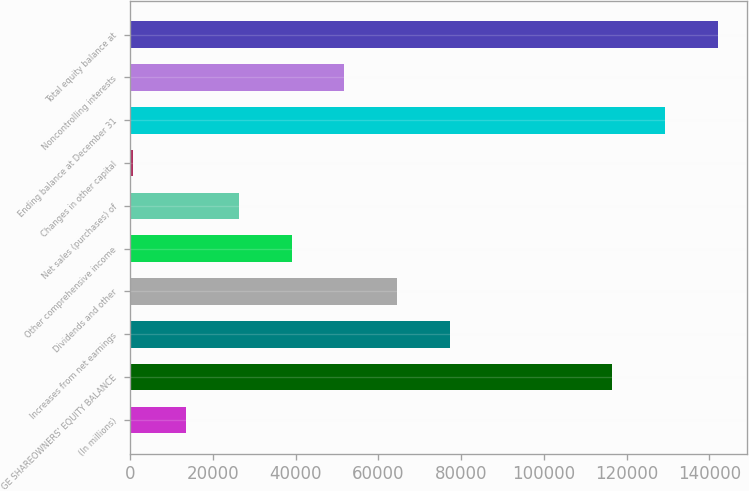Convert chart to OTSL. <chart><loc_0><loc_0><loc_500><loc_500><bar_chart><fcel>(In millions)<fcel>GE SHAREOWNERS' EQUITY BALANCE<fcel>Increases from net earnings<fcel>Dividends and other<fcel>Other comprehensive income<fcel>Net sales (purchases) of<fcel>Changes in other capital<fcel>Ending balance at December 31<fcel>Noncontrolling interests<fcel>Total equity balance at<nl><fcel>13407.7<fcel>116438<fcel>77331.2<fcel>64546.5<fcel>38977.1<fcel>26192.4<fcel>623<fcel>129223<fcel>51761.8<fcel>142007<nl></chart> 